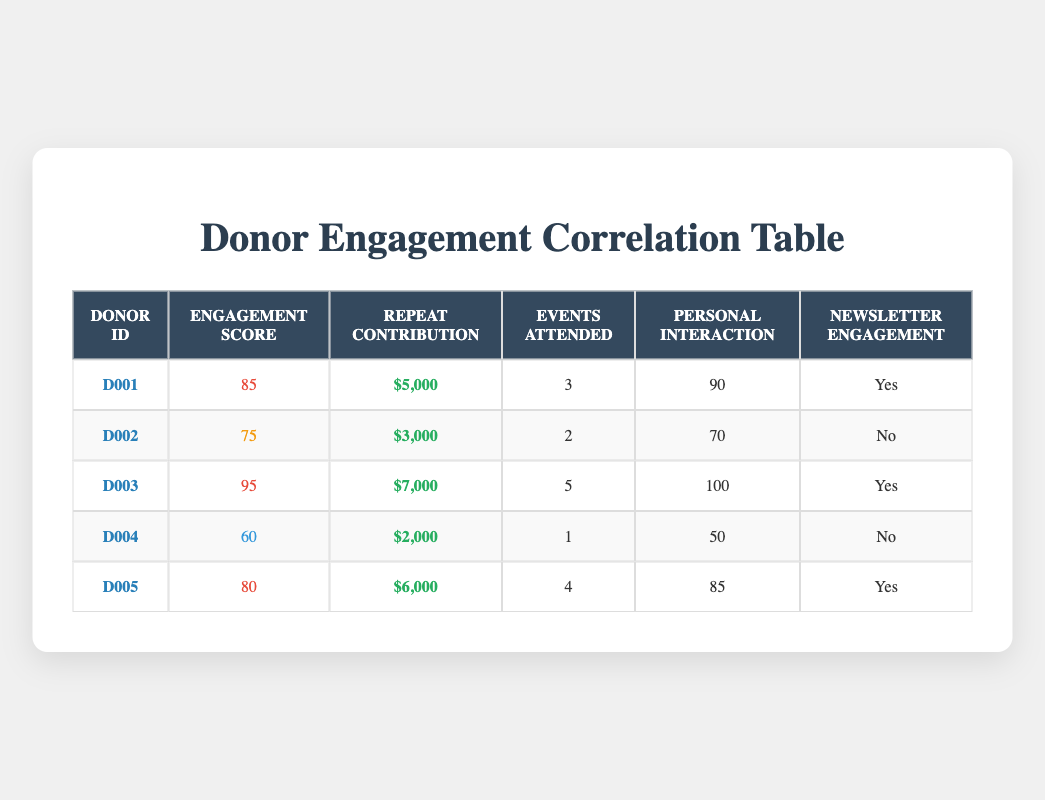What is the engagement activity score of Donor D003? The table lists the engagement activity scores for each donor. For Donor D003, the engagement activity score is displayed as 95 in the corresponding row.
Answer: 95 How much was the repeat contribution amount from Donor D001? By looking at the row for Donor D001, the repeat contribution amount is listed as $5,000.
Answer: $5,000 Which donor attended the most events? The 'Events Attended' column shows the number of events each donor attended. Donor D003 attended 5 events, which is the highest in the table.
Answer: Donor D003 Is there a donor who has a personal interaction score lower than 70? By checking the 'Personal Interaction' column, Donor D004 has a score of 50, which is indeed lower than 70.
Answer: Yes What is the average repeat contribution amount of all donors? To find the average, sum the repeat contributions: (5000 + 3000 + 7000 + 2000 + 6000) = 23000. Then divide by the number of donors (5): 23000 / 5 = 4600.
Answer: $4,600 How many donors engaged with the newsletter? From the 'Newsletter Engagement' column, the donors who engaged with the newsletter are D001, D003, and D005. Counting these, there are 3 donors who engaged.
Answer: 3 Which donor has the lowest engagement activity score and what is that score? The engagement activity scores among the donors are 85, 75, 95, 60, and 80. The lowest score is 60, which corresponds to Donor D004.
Answer: Donor D004, 60 What can be inferred about the relationship between personal interaction scores and repeat contributions? By analyzing the data, higher personal interaction scores correspond to higher repeat contributions in several instances, such as Donor D003 with a score of 100 and a contribution of $7,000. This suggests a positive correlation.
Answer: Positive correlation How many event attendees have an engagement score above 80? Examining the engagement activity scores, Donors D001, D003, and D005 have scores above 80, summing up to a total of 3 donors.
Answer: 3 